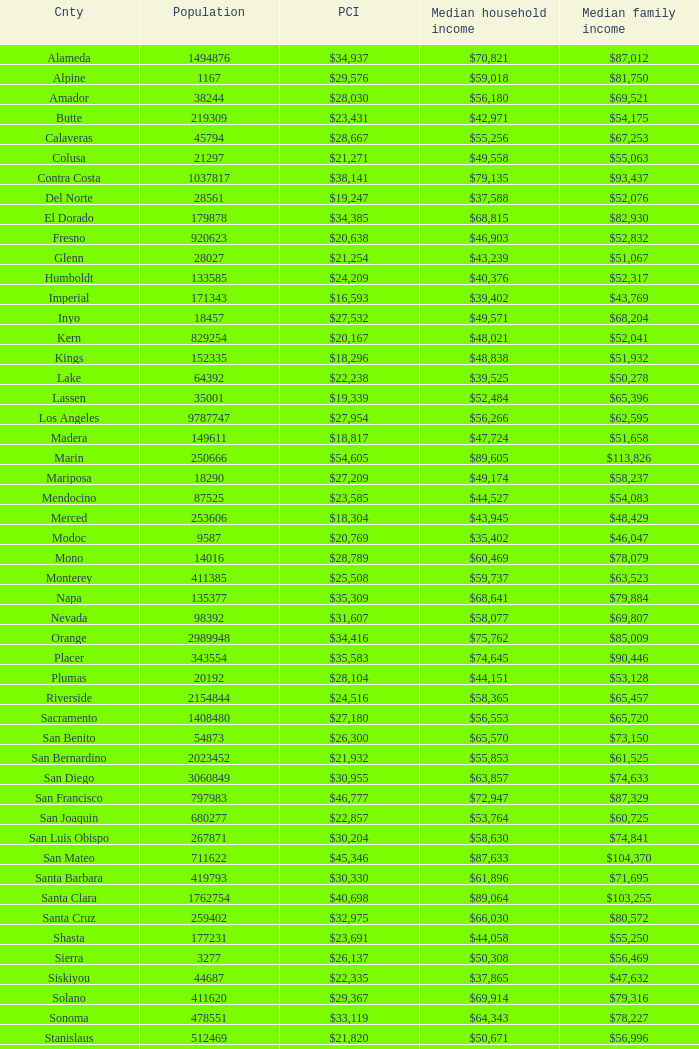What is the per capita income of shasta? $23,691. I'm looking to parse the entire table for insights. Could you assist me with that? {'header': ['Cnty', 'Population', 'PCI', 'Median household income', 'Median family income'], 'rows': [['Alameda', '1494876', '$34,937', '$70,821', '$87,012'], ['Alpine', '1167', '$29,576', '$59,018', '$81,750'], ['Amador', '38244', '$28,030', '$56,180', '$69,521'], ['Butte', '219309', '$23,431', '$42,971', '$54,175'], ['Calaveras', '45794', '$28,667', '$55,256', '$67,253'], ['Colusa', '21297', '$21,271', '$49,558', '$55,063'], ['Contra Costa', '1037817', '$38,141', '$79,135', '$93,437'], ['Del Norte', '28561', '$19,247', '$37,588', '$52,076'], ['El Dorado', '179878', '$34,385', '$68,815', '$82,930'], ['Fresno', '920623', '$20,638', '$46,903', '$52,832'], ['Glenn', '28027', '$21,254', '$43,239', '$51,067'], ['Humboldt', '133585', '$24,209', '$40,376', '$52,317'], ['Imperial', '171343', '$16,593', '$39,402', '$43,769'], ['Inyo', '18457', '$27,532', '$49,571', '$68,204'], ['Kern', '829254', '$20,167', '$48,021', '$52,041'], ['Kings', '152335', '$18,296', '$48,838', '$51,932'], ['Lake', '64392', '$22,238', '$39,525', '$50,278'], ['Lassen', '35001', '$19,339', '$52,484', '$65,396'], ['Los Angeles', '9787747', '$27,954', '$56,266', '$62,595'], ['Madera', '149611', '$18,817', '$47,724', '$51,658'], ['Marin', '250666', '$54,605', '$89,605', '$113,826'], ['Mariposa', '18290', '$27,209', '$49,174', '$58,237'], ['Mendocino', '87525', '$23,585', '$44,527', '$54,083'], ['Merced', '253606', '$18,304', '$43,945', '$48,429'], ['Modoc', '9587', '$20,769', '$35,402', '$46,047'], ['Mono', '14016', '$28,789', '$60,469', '$78,079'], ['Monterey', '411385', '$25,508', '$59,737', '$63,523'], ['Napa', '135377', '$35,309', '$68,641', '$79,884'], ['Nevada', '98392', '$31,607', '$58,077', '$69,807'], ['Orange', '2989948', '$34,416', '$75,762', '$85,009'], ['Placer', '343554', '$35,583', '$74,645', '$90,446'], ['Plumas', '20192', '$28,104', '$44,151', '$53,128'], ['Riverside', '2154844', '$24,516', '$58,365', '$65,457'], ['Sacramento', '1408480', '$27,180', '$56,553', '$65,720'], ['San Benito', '54873', '$26,300', '$65,570', '$73,150'], ['San Bernardino', '2023452', '$21,932', '$55,853', '$61,525'], ['San Diego', '3060849', '$30,955', '$63,857', '$74,633'], ['San Francisco', '797983', '$46,777', '$72,947', '$87,329'], ['San Joaquin', '680277', '$22,857', '$53,764', '$60,725'], ['San Luis Obispo', '267871', '$30,204', '$58,630', '$74,841'], ['San Mateo', '711622', '$45,346', '$87,633', '$104,370'], ['Santa Barbara', '419793', '$30,330', '$61,896', '$71,695'], ['Santa Clara', '1762754', '$40,698', '$89,064', '$103,255'], ['Santa Cruz', '259402', '$32,975', '$66,030', '$80,572'], ['Shasta', '177231', '$23,691', '$44,058', '$55,250'], ['Sierra', '3277', '$26,137', '$50,308', '$56,469'], ['Siskiyou', '44687', '$22,335', '$37,865', '$47,632'], ['Solano', '411620', '$29,367', '$69,914', '$79,316'], ['Sonoma', '478551', '$33,119', '$64,343', '$78,227'], ['Stanislaus', '512469', '$21,820', '$50,671', '$56,996'], ['Sutter', '94192', '$22,464', '$50,010', '$54,737'], ['Tehama', '62985', '$20,689', '$38,753', '$46,805'], ['Trinity', '13711', '$22,551', '$37,672', '$46,980'], ['Tulare', '436234', '$17,986', '$43,550', '$46,881'], ['Tuolumne', '55736', '$26,084', '$47,359', '$59,710'], ['Ventura', '815745', '$32,740', '$76,728', '$86,321'], ['Yolo', '198889', '$28,631', '$57,920', '$74,991']]} 